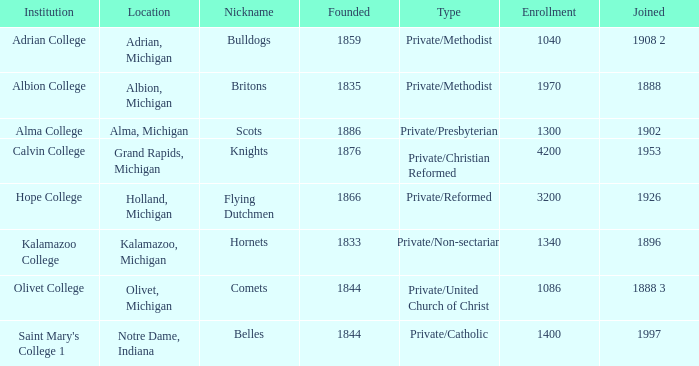In 1953, which of the institutions joined? Calvin College. 